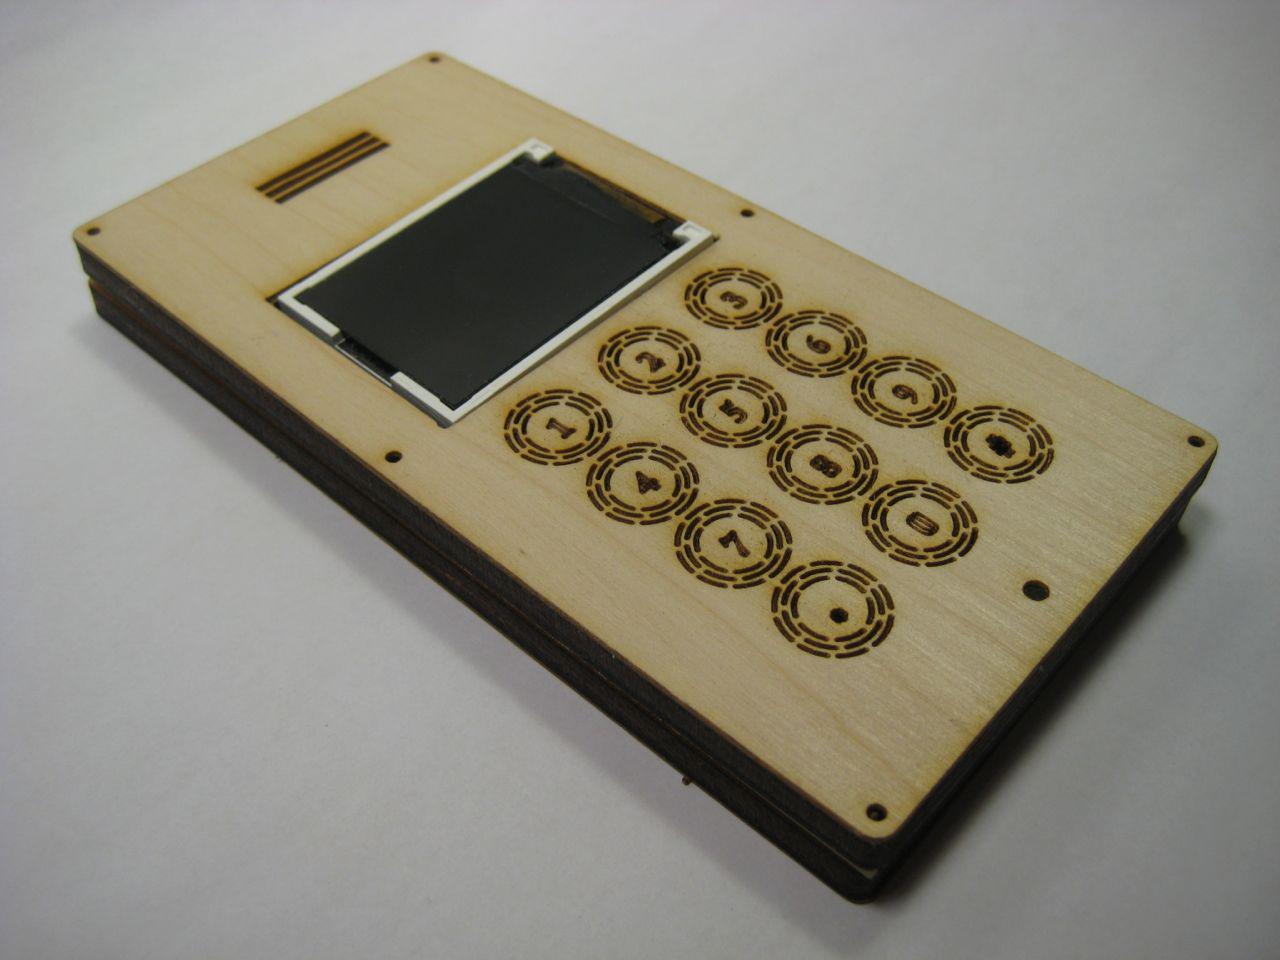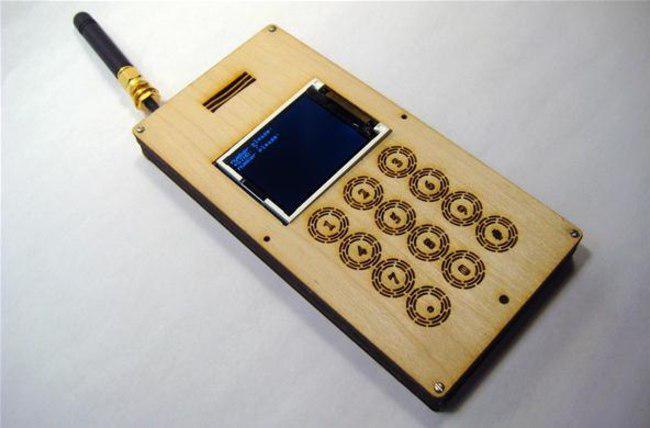The first image is the image on the left, the second image is the image on the right. For the images shown, is this caption "The left image contains a smart phone propped up diagonally." true? Answer yes or no. No. The first image is the image on the left, the second image is the image on the right. Considering the images on both sides, is "At least one cell phone is on a stand facing left." valid? Answer yes or no. No. 